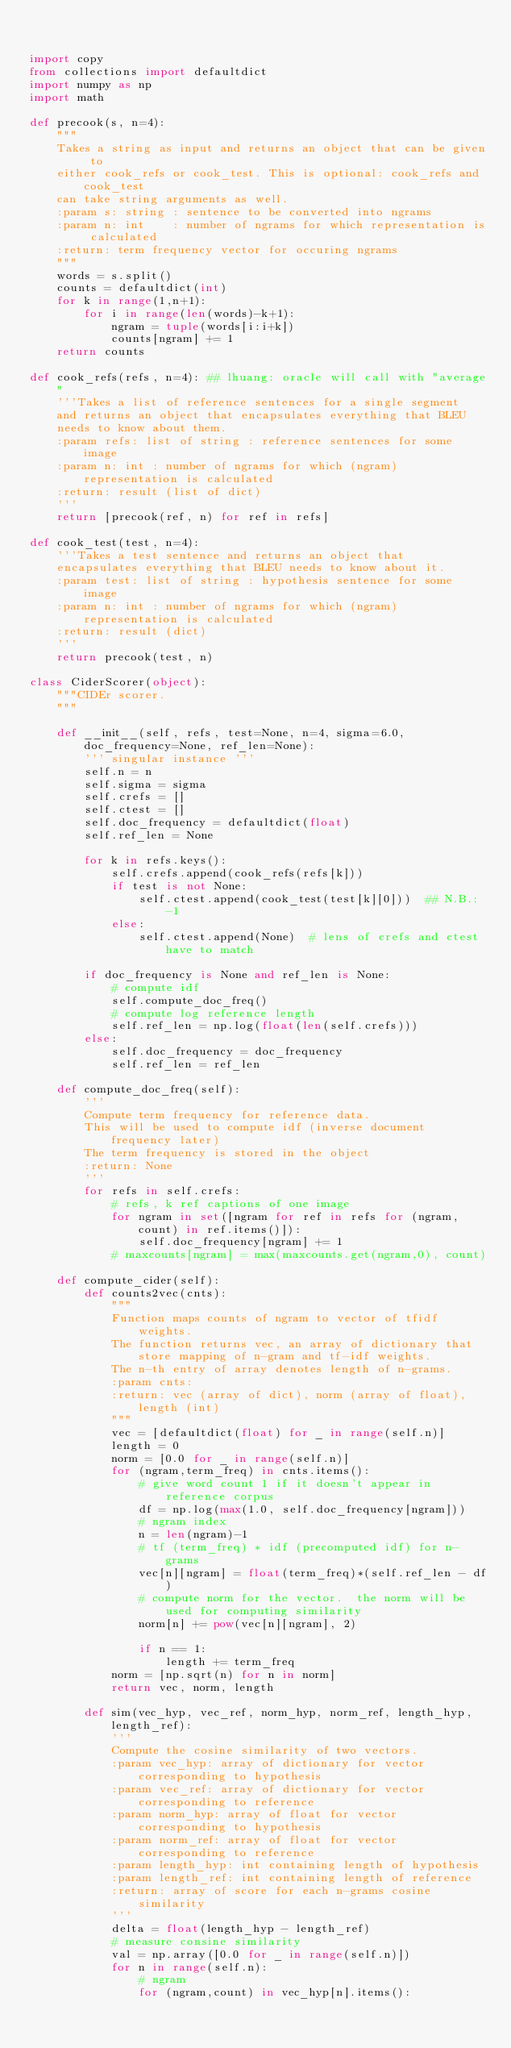Convert code to text. <code><loc_0><loc_0><loc_500><loc_500><_Python_>

import copy
from collections import defaultdict
import numpy as np
import math

def precook(s, n=4):
    """
    Takes a string as input and returns an object that can be given to
    either cook_refs or cook_test. This is optional: cook_refs and cook_test
    can take string arguments as well.
    :param s: string : sentence to be converted into ngrams
    :param n: int    : number of ngrams for which representation is calculated
    :return: term frequency vector for occuring ngrams
    """
    words = s.split()
    counts = defaultdict(int)
    for k in range(1,n+1):
        for i in range(len(words)-k+1):
            ngram = tuple(words[i:i+k])
            counts[ngram] += 1
    return counts

def cook_refs(refs, n=4): ## lhuang: oracle will call with "average"
    '''Takes a list of reference sentences for a single segment
    and returns an object that encapsulates everything that BLEU
    needs to know about them.
    :param refs: list of string : reference sentences for some image
    :param n: int : number of ngrams for which (ngram) representation is calculated
    :return: result (list of dict)
    '''
    return [precook(ref, n) for ref in refs]

def cook_test(test, n=4):
    '''Takes a test sentence and returns an object that
    encapsulates everything that BLEU needs to know about it.
    :param test: list of string : hypothesis sentence for some image
    :param n: int : number of ngrams for which (ngram) representation is calculated
    :return: result (dict)
    '''
    return precook(test, n)

class CiderScorer(object):
    """CIDEr scorer.
    """

    def __init__(self, refs, test=None, n=4, sigma=6.0, doc_frequency=None, ref_len=None):
        ''' singular instance '''
        self.n = n
        self.sigma = sigma
        self.crefs = []
        self.ctest = []
        self.doc_frequency = defaultdict(float)
        self.ref_len = None

        for k in refs.keys():
            self.crefs.append(cook_refs(refs[k]))
            if test is not None:
                self.ctest.append(cook_test(test[k][0]))  ## N.B.: -1
            else:
                self.ctest.append(None)  # lens of crefs and ctest have to match

        if doc_frequency is None and ref_len is None:
            # compute idf
            self.compute_doc_freq()
            # compute log reference length
            self.ref_len = np.log(float(len(self.crefs)))
        else:
            self.doc_frequency = doc_frequency
            self.ref_len = ref_len

    def compute_doc_freq(self):
        '''
        Compute term frequency for reference data.
        This will be used to compute idf (inverse document frequency later)
        The term frequency is stored in the object
        :return: None
        '''
        for refs in self.crefs:
            # refs, k ref captions of one image
            for ngram in set([ngram for ref in refs for (ngram,count) in ref.items()]):
                self.doc_frequency[ngram] += 1
            # maxcounts[ngram] = max(maxcounts.get(ngram,0), count)

    def compute_cider(self):
        def counts2vec(cnts):
            """
            Function maps counts of ngram to vector of tfidf weights.
            The function returns vec, an array of dictionary that store mapping of n-gram and tf-idf weights.
            The n-th entry of array denotes length of n-grams.
            :param cnts:
            :return: vec (array of dict), norm (array of float), length (int)
            """
            vec = [defaultdict(float) for _ in range(self.n)]
            length = 0
            norm = [0.0 for _ in range(self.n)]
            for (ngram,term_freq) in cnts.items():
                # give word count 1 if it doesn't appear in reference corpus
                df = np.log(max(1.0, self.doc_frequency[ngram]))
                # ngram index
                n = len(ngram)-1
                # tf (term_freq) * idf (precomputed idf) for n-grams
                vec[n][ngram] = float(term_freq)*(self.ref_len - df)
                # compute norm for the vector.  the norm will be used for computing similarity
                norm[n] += pow(vec[n][ngram], 2)

                if n == 1:
                    length += term_freq
            norm = [np.sqrt(n) for n in norm]
            return vec, norm, length

        def sim(vec_hyp, vec_ref, norm_hyp, norm_ref, length_hyp, length_ref):
            '''
            Compute the cosine similarity of two vectors.
            :param vec_hyp: array of dictionary for vector corresponding to hypothesis
            :param vec_ref: array of dictionary for vector corresponding to reference
            :param norm_hyp: array of float for vector corresponding to hypothesis
            :param norm_ref: array of float for vector corresponding to reference
            :param length_hyp: int containing length of hypothesis
            :param length_ref: int containing length of reference
            :return: array of score for each n-grams cosine similarity
            '''
            delta = float(length_hyp - length_ref)
            # measure consine similarity
            val = np.array([0.0 for _ in range(self.n)])
            for n in range(self.n):
                # ngram
                for (ngram,count) in vec_hyp[n].items():</code> 